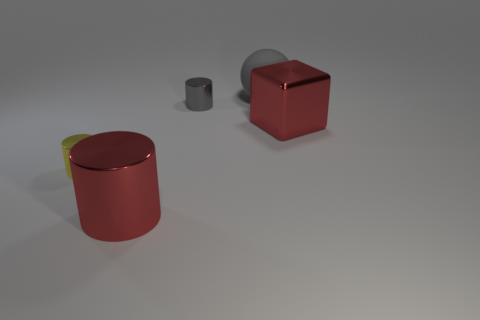Do the big metal block and the small object that is to the left of the gray cylinder have the same color?
Provide a short and direct response. No. What is the material of the small gray cylinder?
Your answer should be compact. Metal. There is a metal thing that is on the right side of the tiny gray metallic object; what color is it?
Your answer should be compact. Red. How many large cylinders are the same color as the large metal block?
Offer a very short reply. 1. What number of cylinders are in front of the small gray metallic thing and behind the red metallic cylinder?
Provide a succinct answer. 1. The yellow metal thing that is the same size as the gray metallic cylinder is what shape?
Give a very brief answer. Cylinder. What is the size of the metallic cube?
Offer a terse response. Large. There is a red thing on the right side of the tiny object on the right side of the red shiny object that is left of the large cube; what is it made of?
Keep it short and to the point. Metal. There is a block that is made of the same material as the yellow cylinder; what is its color?
Ensure brevity in your answer.  Red. There is a big red thing in front of the large metal thing that is behind the small yellow thing; how many yellow things are in front of it?
Ensure brevity in your answer.  0. 